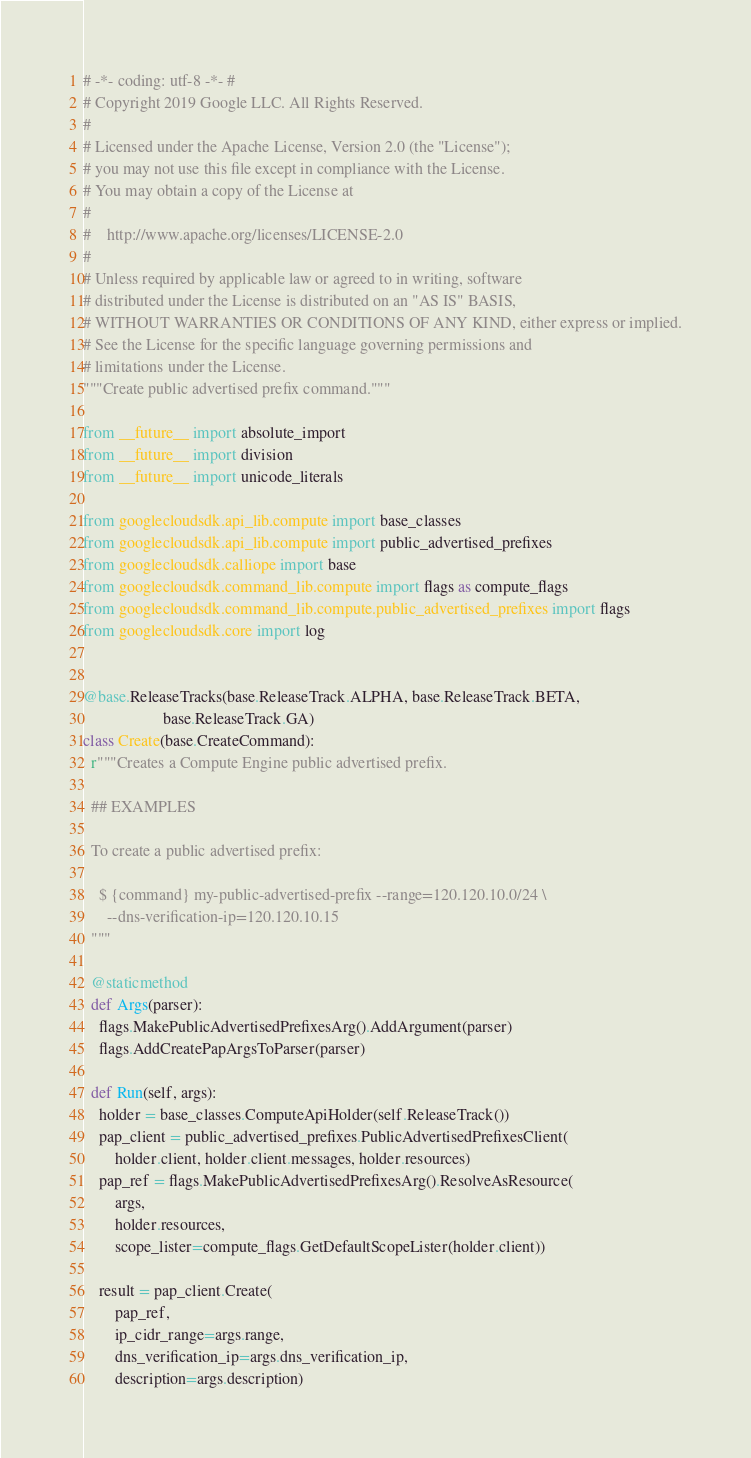<code> <loc_0><loc_0><loc_500><loc_500><_Python_># -*- coding: utf-8 -*- #
# Copyright 2019 Google LLC. All Rights Reserved.
#
# Licensed under the Apache License, Version 2.0 (the "License");
# you may not use this file except in compliance with the License.
# You may obtain a copy of the License at
#
#    http://www.apache.org/licenses/LICENSE-2.0
#
# Unless required by applicable law or agreed to in writing, software
# distributed under the License is distributed on an "AS IS" BASIS,
# WITHOUT WARRANTIES OR CONDITIONS OF ANY KIND, either express or implied.
# See the License for the specific language governing permissions and
# limitations under the License.
"""Create public advertised prefix command."""

from __future__ import absolute_import
from __future__ import division
from __future__ import unicode_literals

from googlecloudsdk.api_lib.compute import base_classes
from googlecloudsdk.api_lib.compute import public_advertised_prefixes
from googlecloudsdk.calliope import base
from googlecloudsdk.command_lib.compute import flags as compute_flags
from googlecloudsdk.command_lib.compute.public_advertised_prefixes import flags
from googlecloudsdk.core import log


@base.ReleaseTracks(base.ReleaseTrack.ALPHA, base.ReleaseTrack.BETA,
                    base.ReleaseTrack.GA)
class Create(base.CreateCommand):
  r"""Creates a Compute Engine public advertised prefix.

  ## EXAMPLES

  To create a public advertised prefix:

    $ {command} my-public-advertised-prefix --range=120.120.10.0/24 \
      --dns-verification-ip=120.120.10.15
  """

  @staticmethod
  def Args(parser):
    flags.MakePublicAdvertisedPrefixesArg().AddArgument(parser)
    flags.AddCreatePapArgsToParser(parser)

  def Run(self, args):
    holder = base_classes.ComputeApiHolder(self.ReleaseTrack())
    pap_client = public_advertised_prefixes.PublicAdvertisedPrefixesClient(
        holder.client, holder.client.messages, holder.resources)
    pap_ref = flags.MakePublicAdvertisedPrefixesArg().ResolveAsResource(
        args,
        holder.resources,
        scope_lister=compute_flags.GetDefaultScopeLister(holder.client))

    result = pap_client.Create(
        pap_ref,
        ip_cidr_range=args.range,
        dns_verification_ip=args.dns_verification_ip,
        description=args.description)</code> 